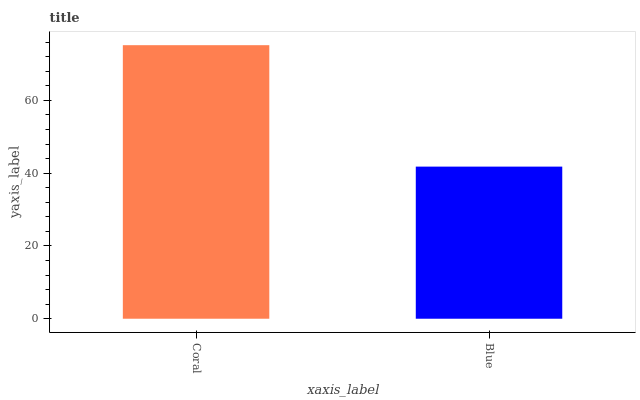Is Blue the minimum?
Answer yes or no. Yes. Is Coral the maximum?
Answer yes or no. Yes. Is Blue the maximum?
Answer yes or no. No. Is Coral greater than Blue?
Answer yes or no. Yes. Is Blue less than Coral?
Answer yes or no. Yes. Is Blue greater than Coral?
Answer yes or no. No. Is Coral less than Blue?
Answer yes or no. No. Is Coral the high median?
Answer yes or no. Yes. Is Blue the low median?
Answer yes or no. Yes. Is Blue the high median?
Answer yes or no. No. Is Coral the low median?
Answer yes or no. No. 